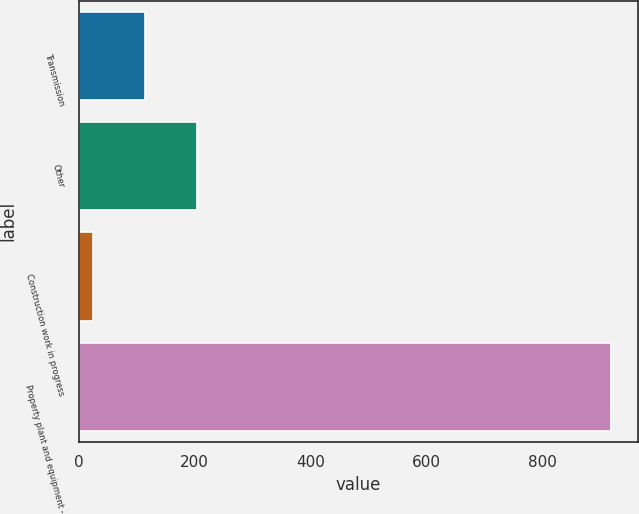Convert chart. <chart><loc_0><loc_0><loc_500><loc_500><bar_chart><fcel>Transmission<fcel>Other<fcel>Construction work in progress<fcel>Property plant and equipment -<nl><fcel>114.4<fcel>203.8<fcel>25<fcel>919<nl></chart> 